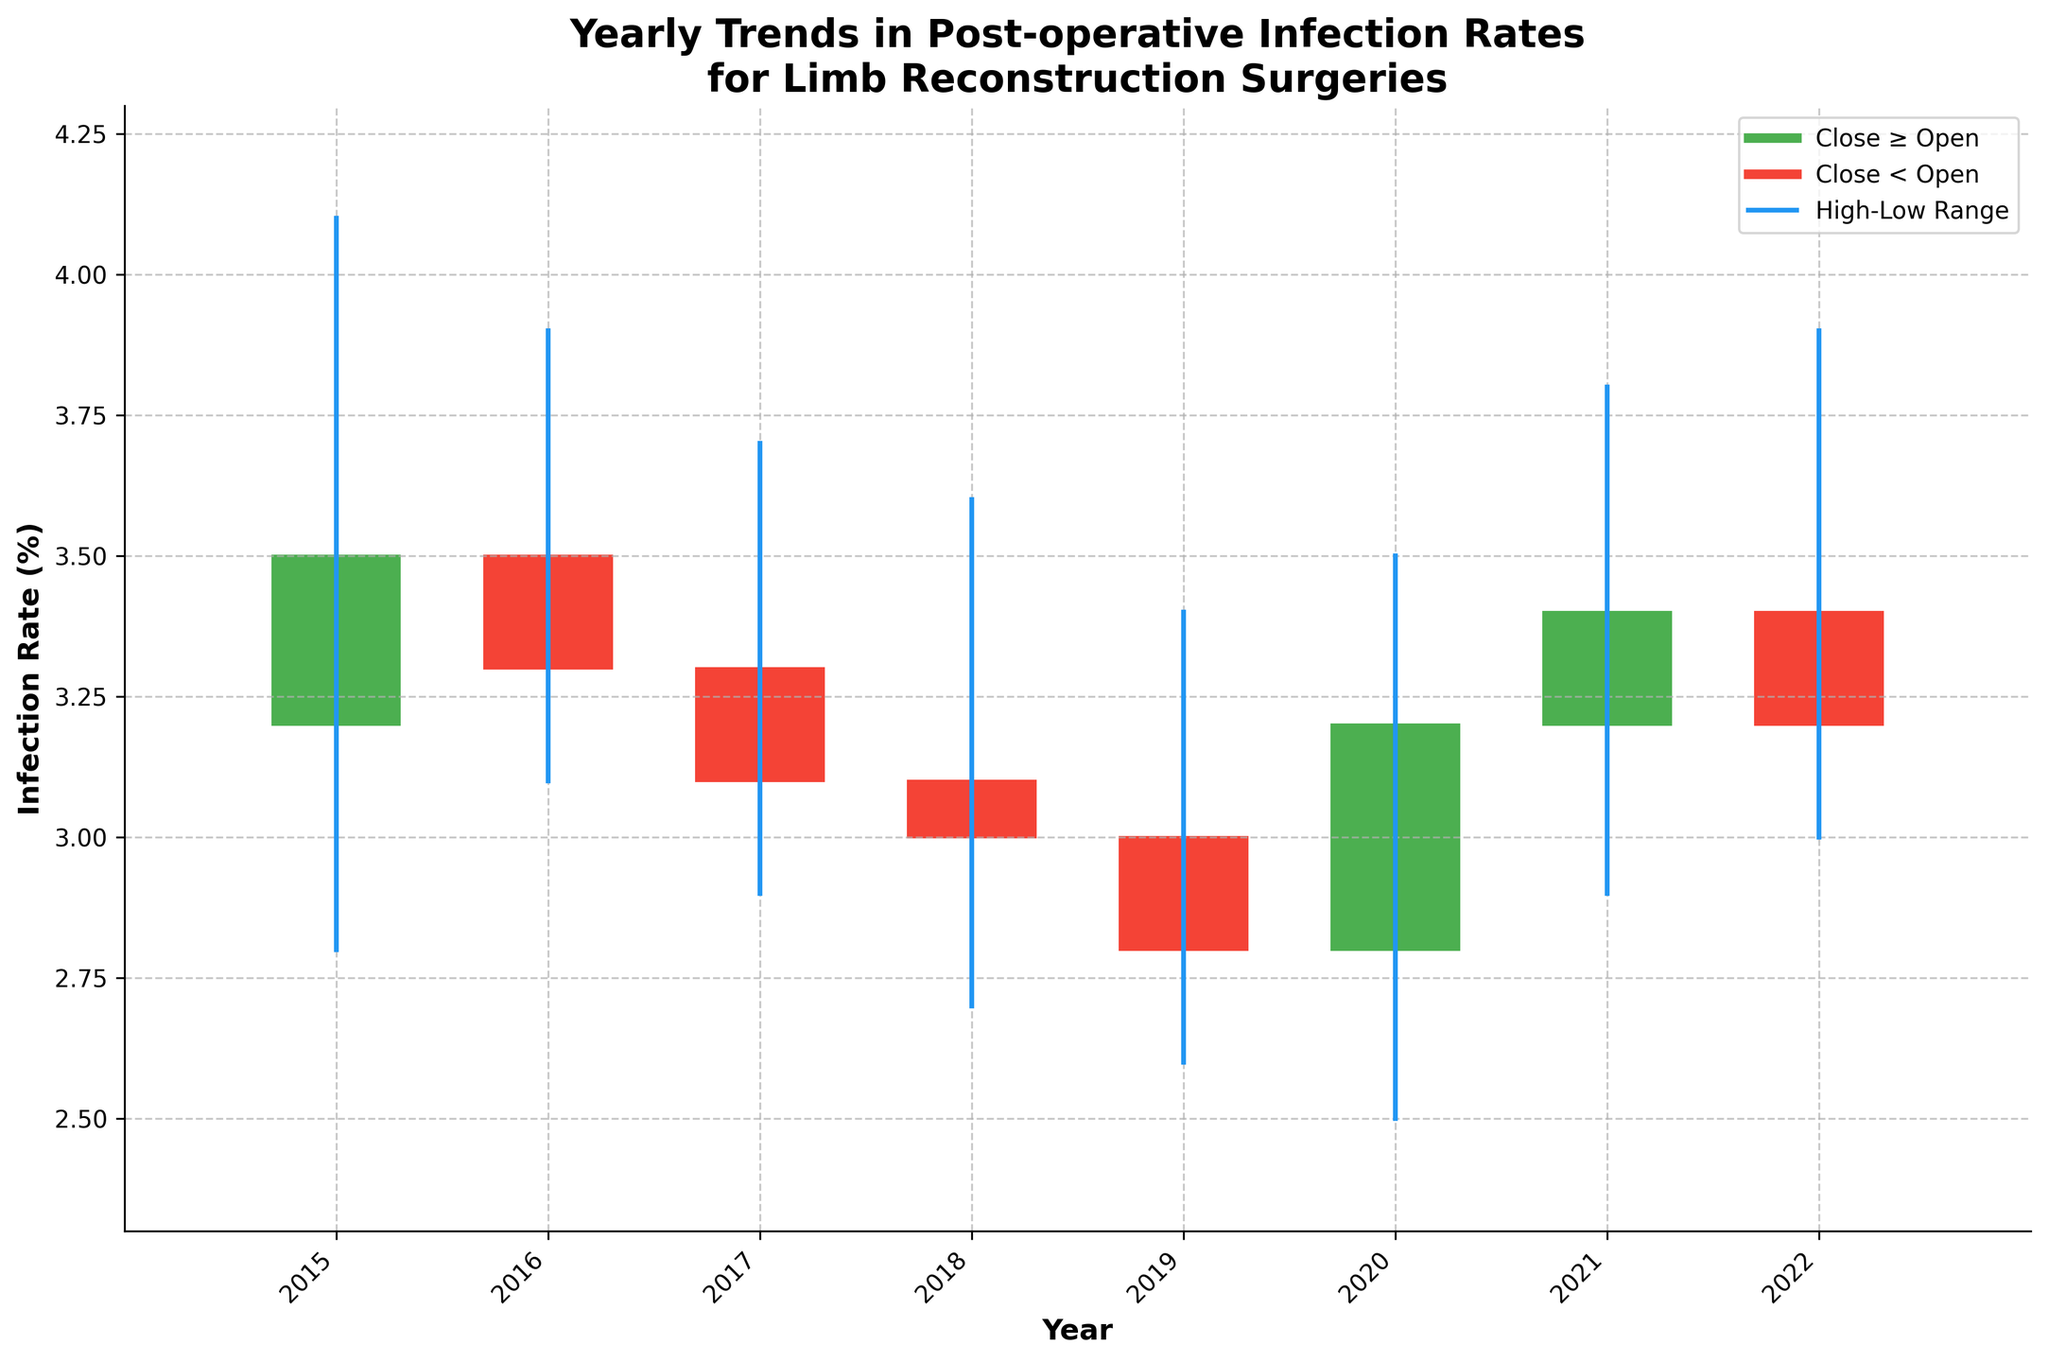What is the infection rate for 2015 when the surgeries open? The infection rate for 2015 when surgeries open is given directly in the plot at the 'Open' position on the y-axis. You can see the opening rate on the y-axis vertical line corresponding to 2015.
Answer: 3.2% Which year had the highest infection rate at any point, and what was it? From the plot, to find the year with the highest infection rate, look for the maximum value on the y-axis at the 'High' points across all years. The highest rate was observed in 2015, with a 'High' value of 4.1%.
Answer: 2015, 4.1% What was the infection rate trend between 2016 and 2019? To understand the trend between 2016 and 2019, observe the 'Close' rates for each year and note if they increase or decrease when moving from one year to the next. The 'Close' rates decrease from 3.3% in 2016 to 2.8% in 2019, indicating a declining trend.
Answer: Decreasing How many years saw a decrease in infection rate from the start to the end of the year? To determine the number of years with a decrease in infection rate from open to close, compare the 'Open' and 'Close' values for each year. If 'Close' is less than 'Open', it indicates a decrease. This scenario occurs in 2016, 2017, 2018, and 2019.
Answer: 4 years Which year had the smallest range of infection rates, and what was the range? To find the year with the smallest range, compute the difference between the 'High' and 'Low' values for each year, then identify the smallest difference. The smallest range is in 2019, with a range of 3.4% - 2.6% = 0.8%.
Answer: 2019, 0.8% What is the title of the plot? Directly reading from the plot, the title is displayed at the top, providing an overview of the visualization.
Answer: Yearly Trends in Post-operative Infection Rates for Limb Reconstruction Surgeries How did the infection rate change from 2015 to 2022? Compare the 'Close' values for 2015 and 2022. From the plot, the 'Close' value in 2015 is 3.5%, and in 2022, it is 3.2%. Thus, there is a decrease in the infection rate.
Answer: Decreased Which year experienced the largest fluctuation in infection rates, and what were the values? To find the largest fluctuation, look for the year with the greatest difference between the 'High' and 'Low' values. The year 2015 experienced the largest fluctuation with a high of 4.1% and a low of 2.8%, resulting in a difference of 4.1% - 2.8% = 1.3%.
Answer: 2015, 1.3% What visual elements indicate an increase in the infection rate for a year? Identifying a yearly increase involves examining the color of the rectangles. Years with a green (up color) rectangle, indicating 'Close' is greater than 'Open'.
Answer: Green rectangle What was the infection rate range in 2020? Look at the 'Low' and 'High' values directly on the y-axis for the year 2020 to determine the range. The 'Low' was 2.5% and the 'High' was 3.5%, hence the range is 3.5% - 2.5% = 1.0%.
Answer: 1.0% 